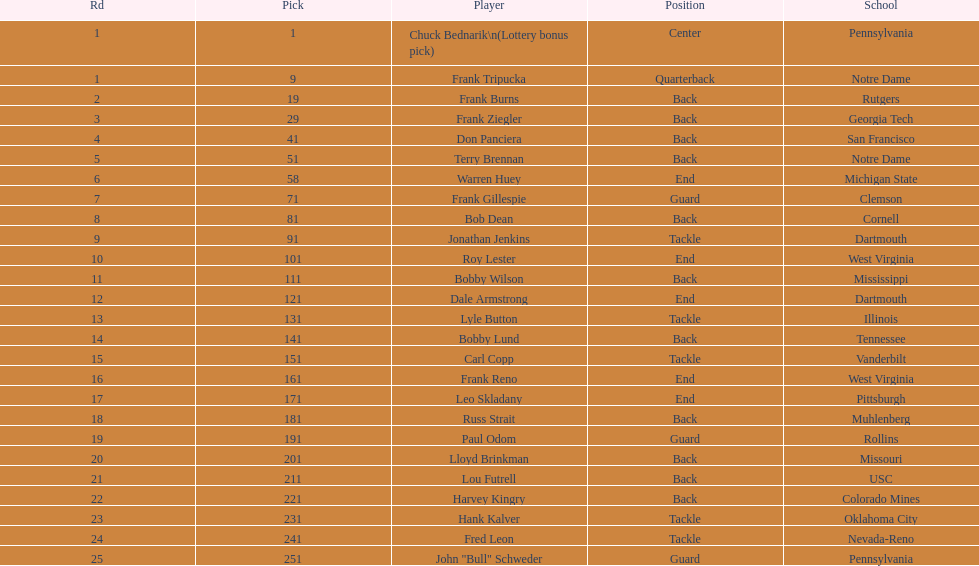Who has same position as frank gillespie? Paul Odom, John "Bull" Schweder. 